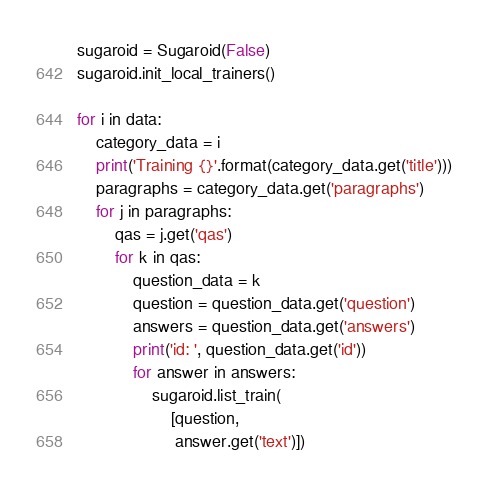<code> <loc_0><loc_0><loc_500><loc_500><_Python_>
sugaroid = Sugaroid(False)
sugaroid.init_local_trainers()

for i in data:
    category_data = i
    print('Training {}'.format(category_data.get('title')))
    paragraphs = category_data.get('paragraphs')
    for j in paragraphs:
        qas = j.get('qas')
        for k in qas:
            question_data = k
            question = question_data.get('question')
            answers = question_data.get('answers')
            print('id: ', question_data.get('id'))
            for answer in answers:
                sugaroid.list_train(
                    [question,
                     answer.get('text')])
</code> 